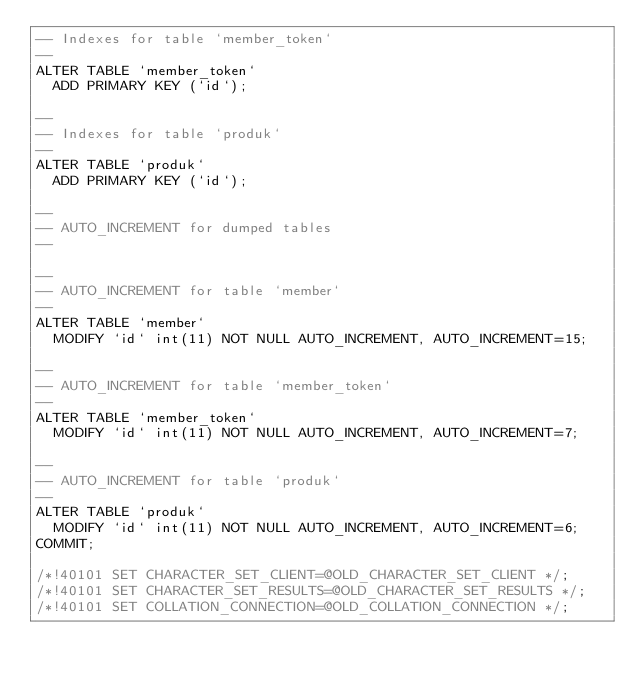Convert code to text. <code><loc_0><loc_0><loc_500><loc_500><_SQL_>-- Indexes for table `member_token`
--
ALTER TABLE `member_token`
  ADD PRIMARY KEY (`id`);

--
-- Indexes for table `produk`
--
ALTER TABLE `produk`
  ADD PRIMARY KEY (`id`);

--
-- AUTO_INCREMENT for dumped tables
--

--
-- AUTO_INCREMENT for table `member`
--
ALTER TABLE `member`
  MODIFY `id` int(11) NOT NULL AUTO_INCREMENT, AUTO_INCREMENT=15;

--
-- AUTO_INCREMENT for table `member_token`
--
ALTER TABLE `member_token`
  MODIFY `id` int(11) NOT NULL AUTO_INCREMENT, AUTO_INCREMENT=7;

--
-- AUTO_INCREMENT for table `produk`
--
ALTER TABLE `produk`
  MODIFY `id` int(11) NOT NULL AUTO_INCREMENT, AUTO_INCREMENT=6;
COMMIT;

/*!40101 SET CHARACTER_SET_CLIENT=@OLD_CHARACTER_SET_CLIENT */;
/*!40101 SET CHARACTER_SET_RESULTS=@OLD_CHARACTER_SET_RESULTS */;
/*!40101 SET COLLATION_CONNECTION=@OLD_COLLATION_CONNECTION */;
</code> 